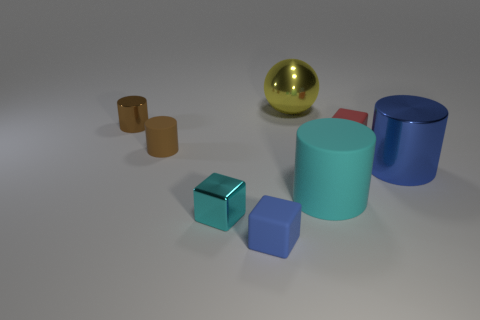What number of large things have the same material as the small blue object?
Provide a succinct answer. 1. There is a small brown matte cylinder; how many small cylinders are to the left of it?
Keep it short and to the point. 1. Do the cylinder that is right of the big matte cylinder and the thing in front of the metallic block have the same material?
Your answer should be very brief. No. Are there more small brown things on the left side of the big cyan rubber thing than brown cylinders on the right side of the brown matte thing?
Your answer should be compact. Yes. What is the material of the other cylinder that is the same color as the tiny metal cylinder?
Offer a very short reply. Rubber. Is there anything else that is the same shape as the yellow thing?
Provide a short and direct response. No. There is a tiny thing that is on the right side of the tiny cyan metal object and behind the tiny blue rubber thing; what is its material?
Give a very brief answer. Rubber. Are the cyan block and the tiny cube right of the yellow ball made of the same material?
Your answer should be very brief. No. What number of things are either tiny green objects or large things that are right of the yellow metal thing?
Provide a short and direct response. 2. Do the rubber block in front of the tiny red cube and the brown object behind the tiny brown matte cylinder have the same size?
Give a very brief answer. Yes. 